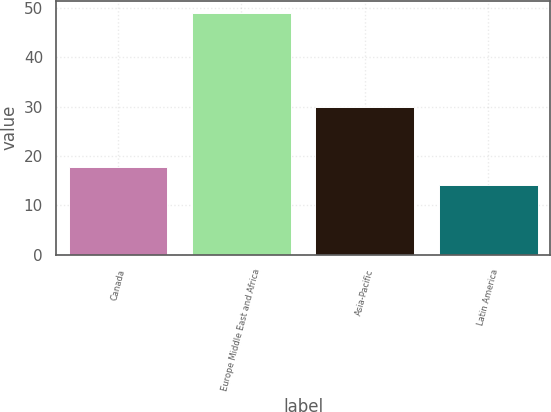Convert chart. <chart><loc_0><loc_0><loc_500><loc_500><bar_chart><fcel>Canada<fcel>Europe Middle East and Africa<fcel>Asia-Pacific<fcel>Latin America<nl><fcel>17.68<fcel>49<fcel>29.9<fcel>14.2<nl></chart> 